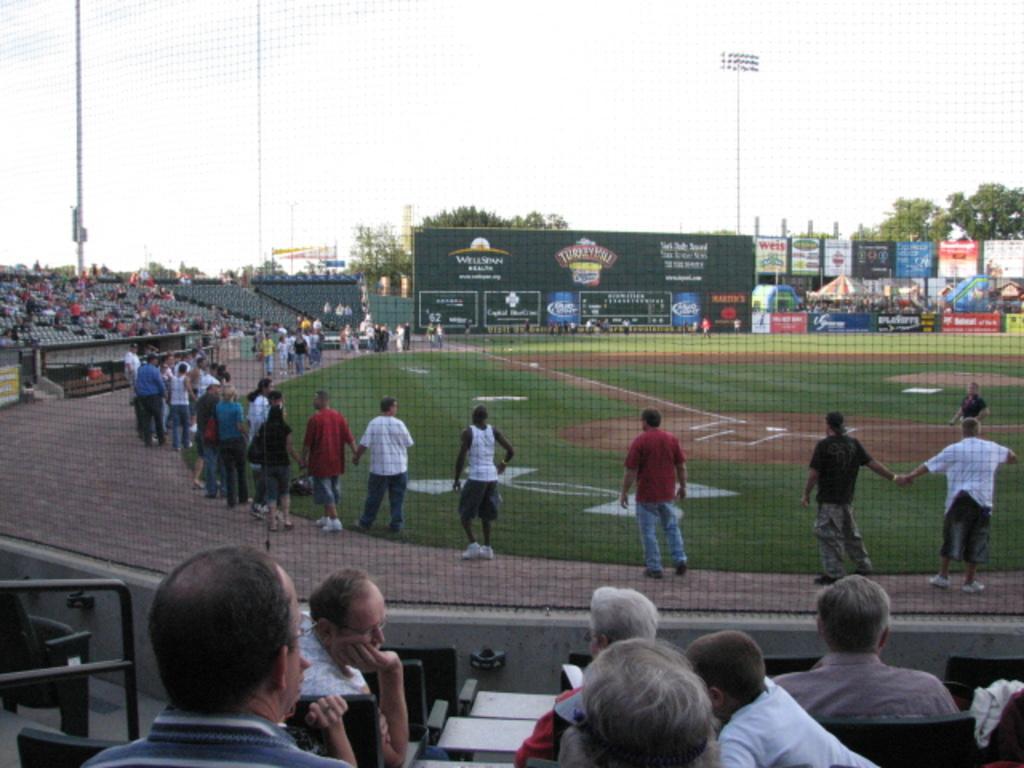In one or two sentences, can you explain what this image depicts? This image is clicked in a stadium. There are many people in the image. At the bottom, there is ground. To the left, there are seats in the stadium. In the front, there is a banner and score board. To the right, there are stalls and trees. 